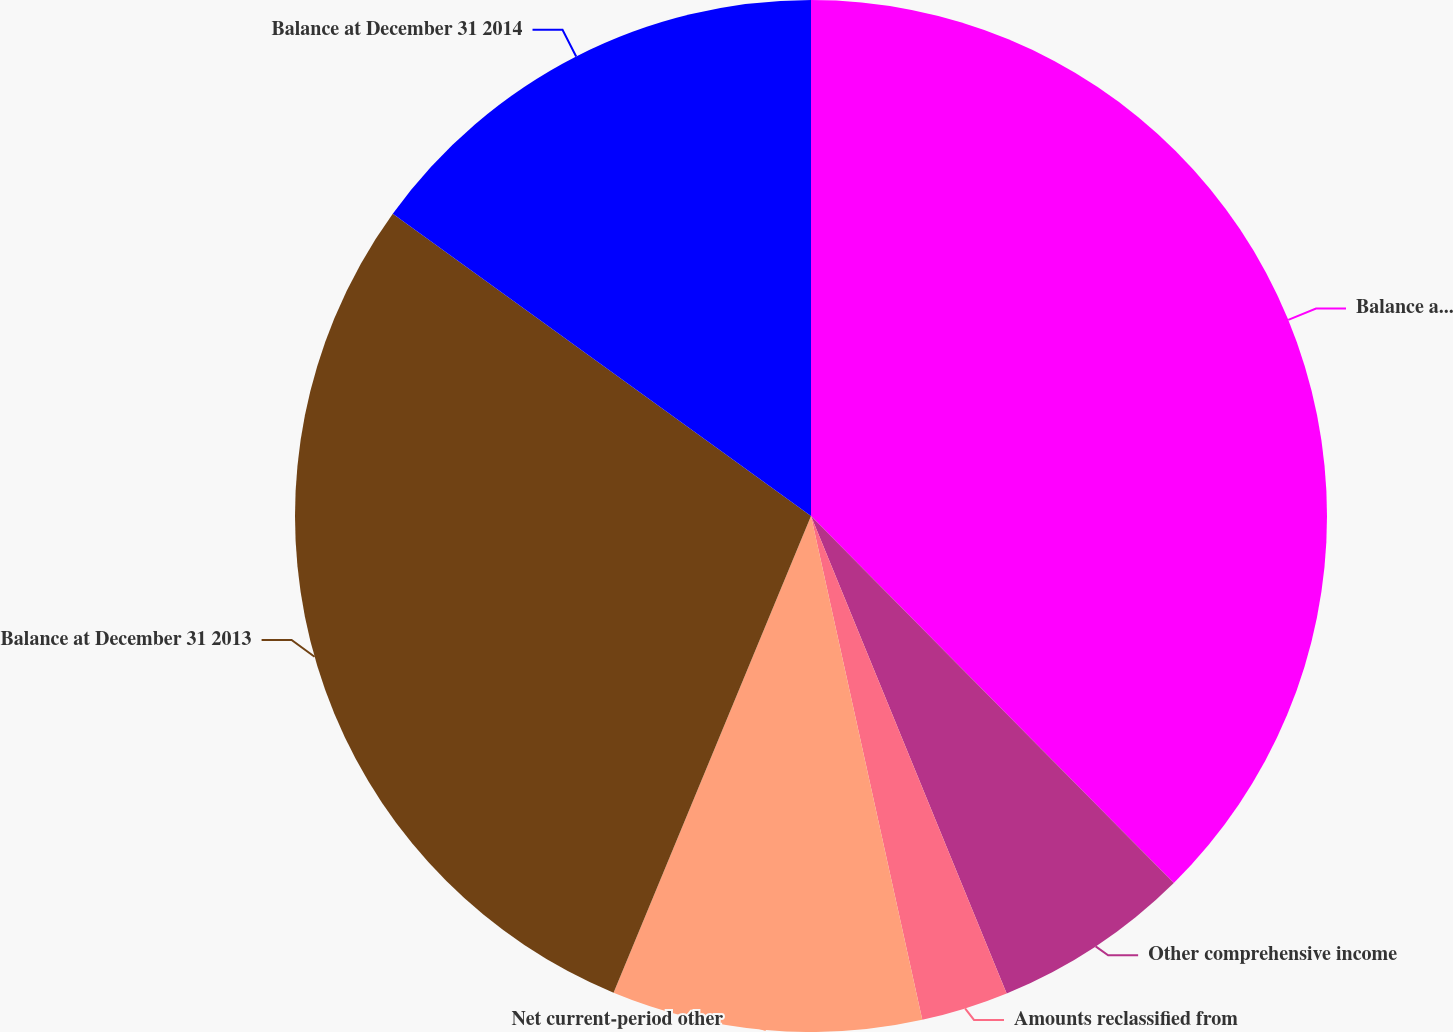Convert chart. <chart><loc_0><loc_0><loc_500><loc_500><pie_chart><fcel>Balance at December 31 2012<fcel>Other comprehensive income<fcel>Amounts reclassified from<fcel>Net current-period other<fcel>Balance at December 31 2013<fcel>Balance at December 31 2014<nl><fcel>37.59%<fcel>6.22%<fcel>2.73%<fcel>9.71%<fcel>28.71%<fcel>15.04%<nl></chart> 